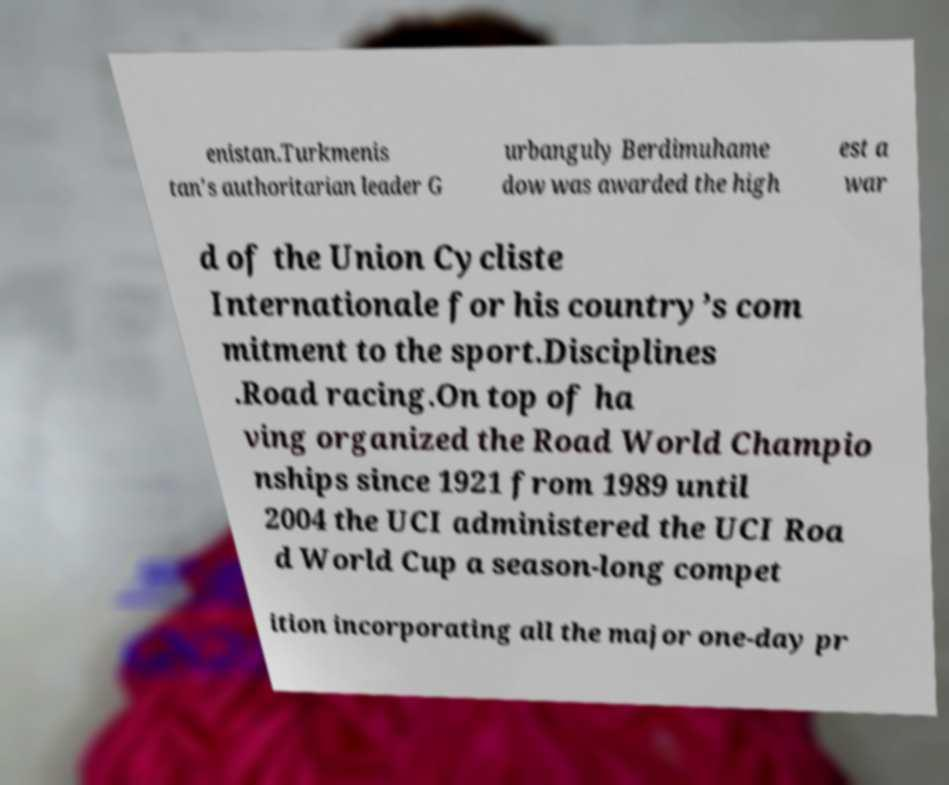Could you extract and type out the text from this image? enistan.Turkmenis tan′s authoritarian leader G urbanguly Berdimuhame dow was awarded the high est a war d of the Union Cycliste Internationale for his country’s com mitment to the sport.Disciplines .Road racing.On top of ha ving organized the Road World Champio nships since 1921 from 1989 until 2004 the UCI administered the UCI Roa d World Cup a season-long compet ition incorporating all the major one-day pr 